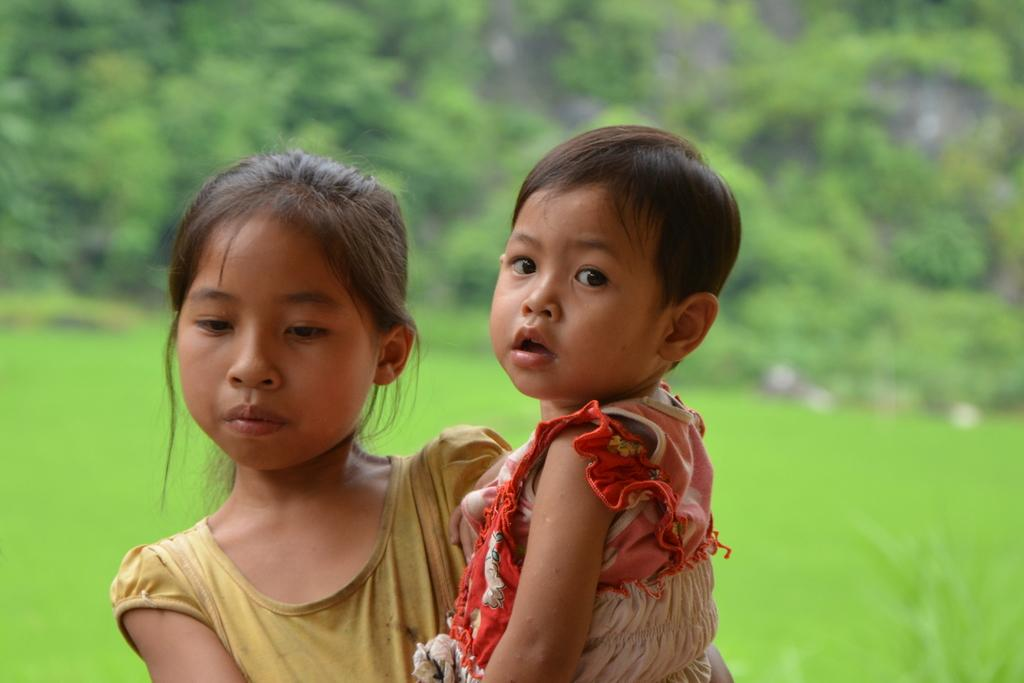What is the main subject of the image? The main subject of the image is a girl. What is the girl doing in the image? The girl is holding a baby. What type of natural environment is visible in the image? There is grass visible in the image. What can be seen in the background of the image? There are trees in the background of the image. What type of experience does the girl have with the locket in the image? There is no locket present in the image, so it cannot be determined if the girl has any experience with one. Can you tell me if there is any blood visible in the image? There is no blood visible in the image. 